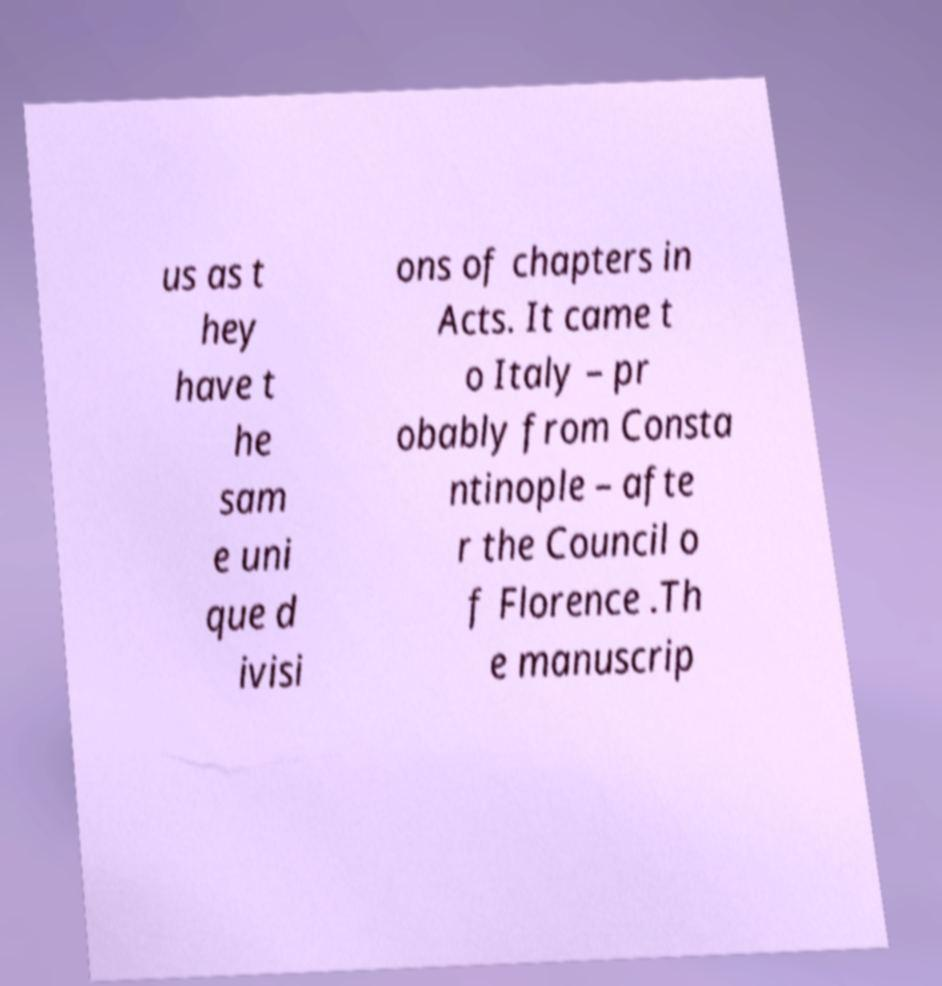Can you accurately transcribe the text from the provided image for me? us as t hey have t he sam e uni que d ivisi ons of chapters in Acts. It came t o Italy – pr obably from Consta ntinople – afte r the Council o f Florence .Th e manuscrip 